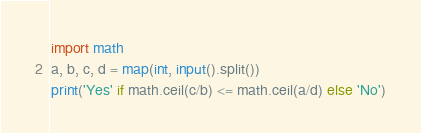Convert code to text. <code><loc_0><loc_0><loc_500><loc_500><_Python_>import math
a, b, c, d = map(int, input().split())
print('Yes' if math.ceil(c/b) <= math.ceil(a/d) else 'No')</code> 